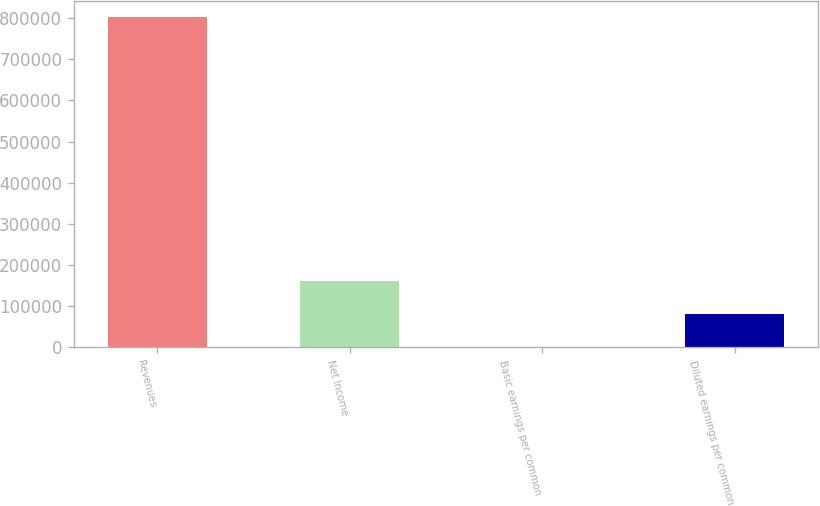Convert chart to OTSL. <chart><loc_0><loc_0><loc_500><loc_500><bar_chart><fcel>Revenues<fcel>Net Income<fcel>Basic earnings per common<fcel>Diluted earnings per common<nl><fcel>801725<fcel>160345<fcel>0.32<fcel>80172.8<nl></chart> 